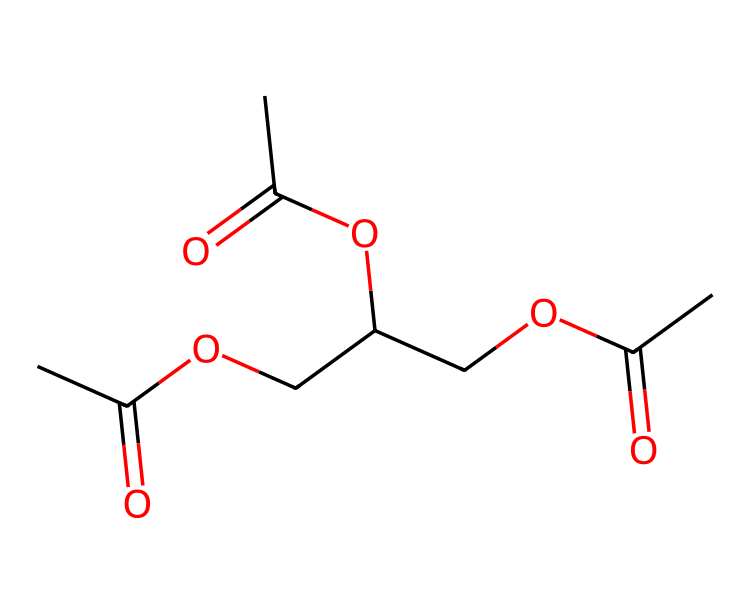What is the molecular formula of triacetin? To determine the molecular formula from the SMILES representation, we start with identifying each type of atom represented: counting carbon (C), hydrogen (H), and oxygen (O) atoms. The chemical is composed of 9 carbon atoms, 14 hydrogen atoms, and 6 oxygen atoms, giving us the formula C9H14O6.
Answer: C9H14O6 How many ester functional groups are present in triacetin? The ester functional group is identified by the structure "RCOOR'". In triacetin, there are three occurrences of the -O- linkage connected to carbonyl groups (C=O), indicating three ester functional groups are present.
Answer: 3 What type of reaction is involved in the formation of triacetin? Triacetin is formed through the reaction of glycerol and acetic anhydride or acetic acid, which is a condensation reaction. During this process, water is released as the ester bonds are formed.
Answer: condensation What is the purpose of triacetin in medical device coatings? Triacetin serves as a plasticizer in medical device coatings. Plasticizers are used to enhance the flexibility, workability, and durability of polymers used in medical devices, making them more suitable for applications where they need to bend or stretch.
Answer: plasticizer Which atoms are involved in the carbonyl groups of triacetin? Carbonyl groups are characterized by the carbon atom double-bonded to an oxygen atom (C=O). In triacetin, the carbon atoms responsible for the carbonyl groups are located in the ester linkages, specifically where the three acetyl groups are connected to the glycerol backbone.
Answer: carbon and oxygen 